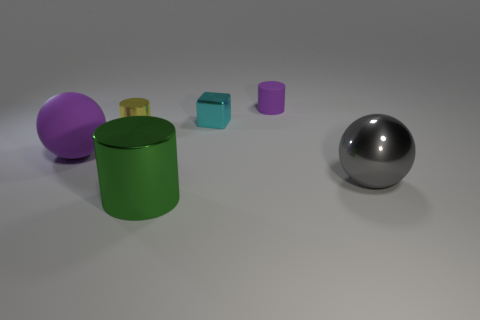Subtract all metal cylinders. How many cylinders are left? 1 Add 4 small rubber cylinders. How many objects exist? 10 Subtract 1 yellow cylinders. How many objects are left? 5 Subtract all cubes. How many objects are left? 5 Subtract all brown blocks. Subtract all red spheres. How many blocks are left? 1 Subtract all large gray balls. Subtract all large gray things. How many objects are left? 4 Add 4 purple rubber spheres. How many purple rubber spheres are left? 5 Add 6 brown matte cubes. How many brown matte cubes exist? 6 